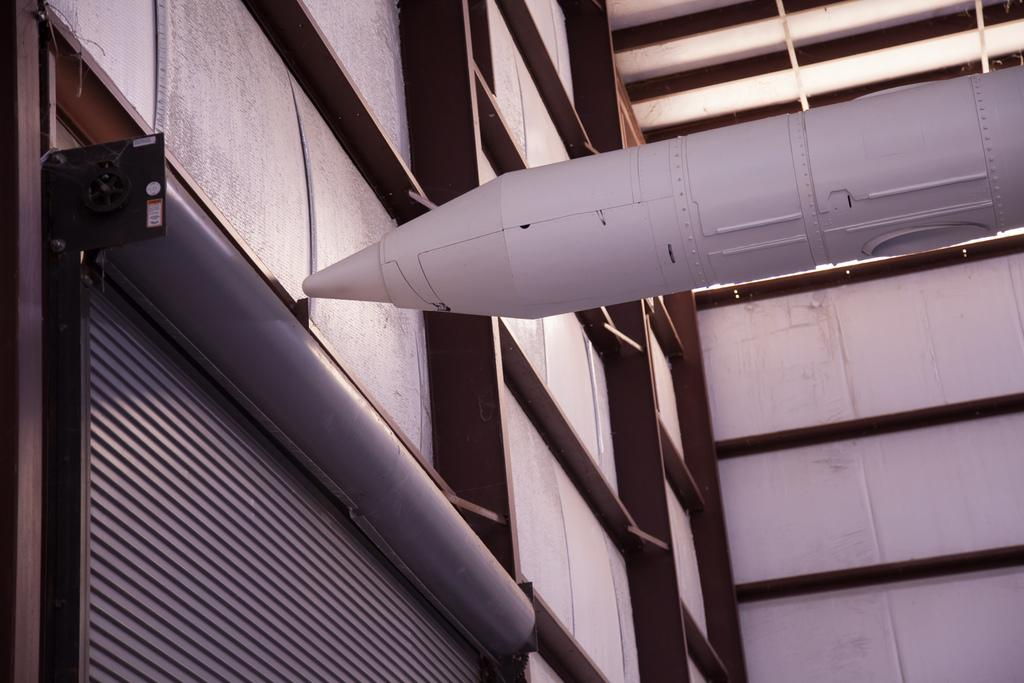What type of object is the main subject of the image? The main subject of the image is a rocket. Can you describe the appearance of the rocket? The rocket is white in color. What other objects can be seen in the image? There is a rolling shutter and a wall with iron pillars in the image. What type of jar is placed on the rocket in the image? There is no jar present on the rocket in the image. Is there a hat visible on the rocket in the image? There is no hat visible on the rocket in the image. 